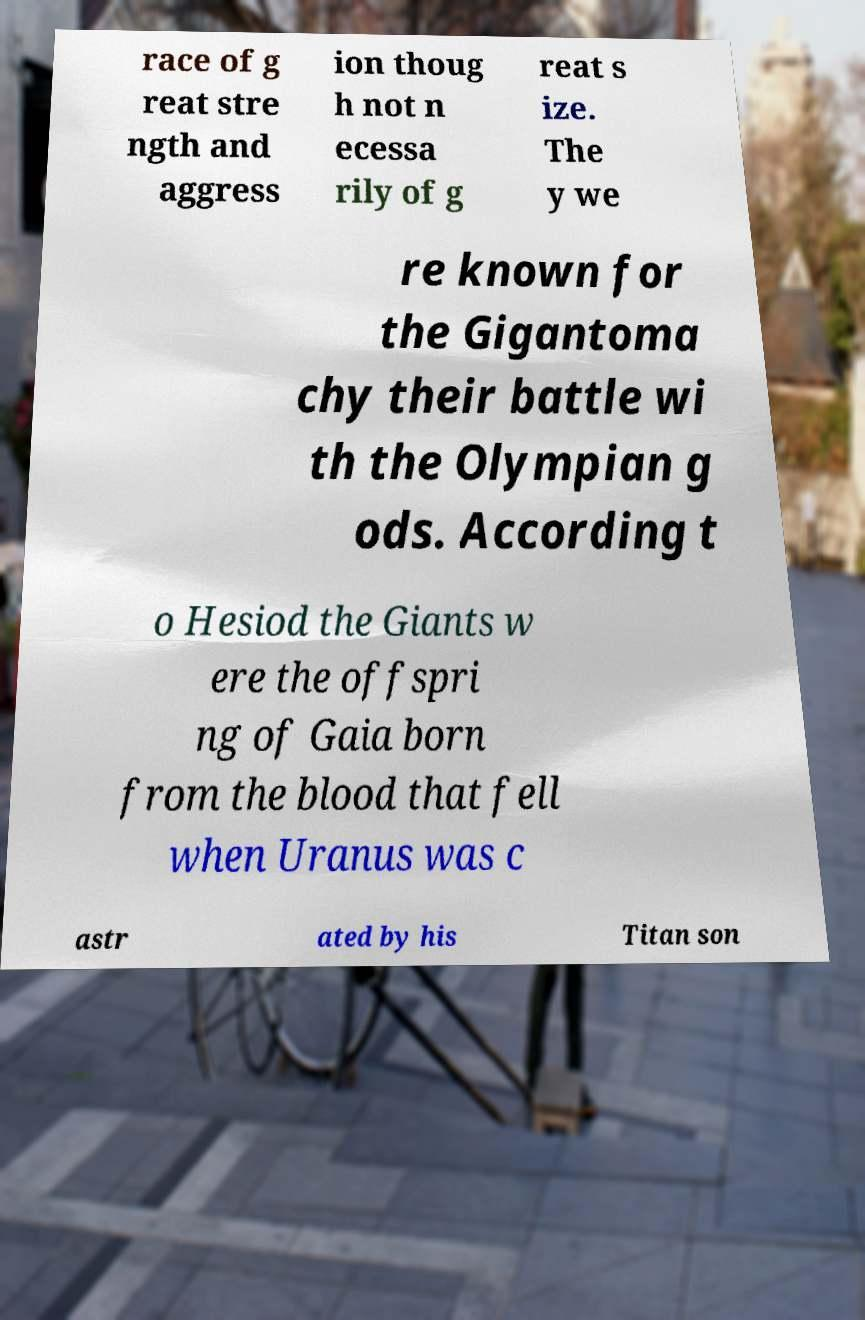Could you assist in decoding the text presented in this image and type it out clearly? race of g reat stre ngth and aggress ion thoug h not n ecessa rily of g reat s ize. The y we re known for the Gigantoma chy their battle wi th the Olympian g ods. According t o Hesiod the Giants w ere the offspri ng of Gaia born from the blood that fell when Uranus was c astr ated by his Titan son 